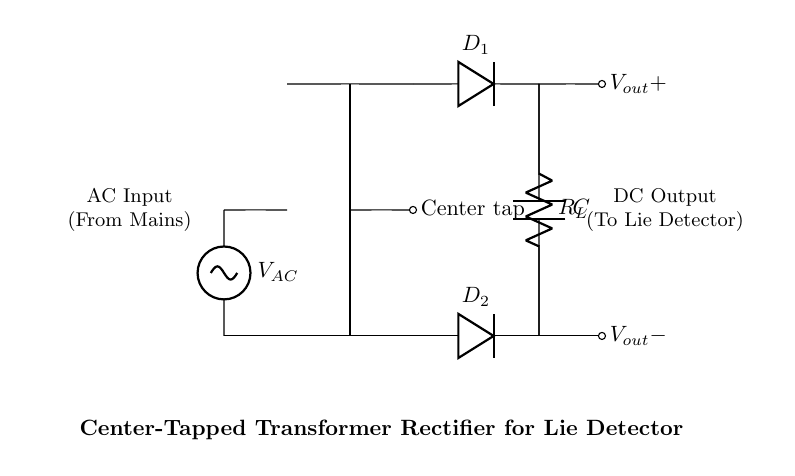What type of transformer is used in this circuit? The circuit diagram specifies a center-tapped transformer, as indicated by the label on the center tap. This type allows for two equal AC voltages from a single winding.
Answer: center-tapped transformer How many diodes are present in the circuit? The diagram shows two diodes, marked as D1 and D2, connected to the outputs of the transformer. This is a standard configuration in a full-wave rectifier circuit.
Answer: 2 What is the function of the capacitor in this circuit? The capacitor, labeled C, acts as a filter to smooth out the rectified voltage, reducing ripples in the DC output and providing more stable power to the lie detector.
Answer: filter What is the output polarity of this rectifier circuit? The circuit indicates that the positive output voltage is designated as Vout+, while the negative output is marked as Vout-. This clear labeling shows the direction of current flow after rectification.
Answer: positive and negative What is the importance of the center tap in this circuit? The center tap allows the transformer to provide two voltage outputs to the diodes, enabling full-wave rectification, ensuring that both halves of the AC waveform contribute to the output voltage.
Answer: full-wave rectification What load is represented in the circuit? The load in the diagram is represented by R_L, which signifies the resistor representing the lie detector's operational components. This indicates the circuit’s functionality in its intended application.
Answer: R_L What does the AC input label indicate? The AC input label signifies that this is the source of alternating current voltage from the mains supply, necessary for the transformer to function and produce the required AC for rectification.
Answer: AC Input 